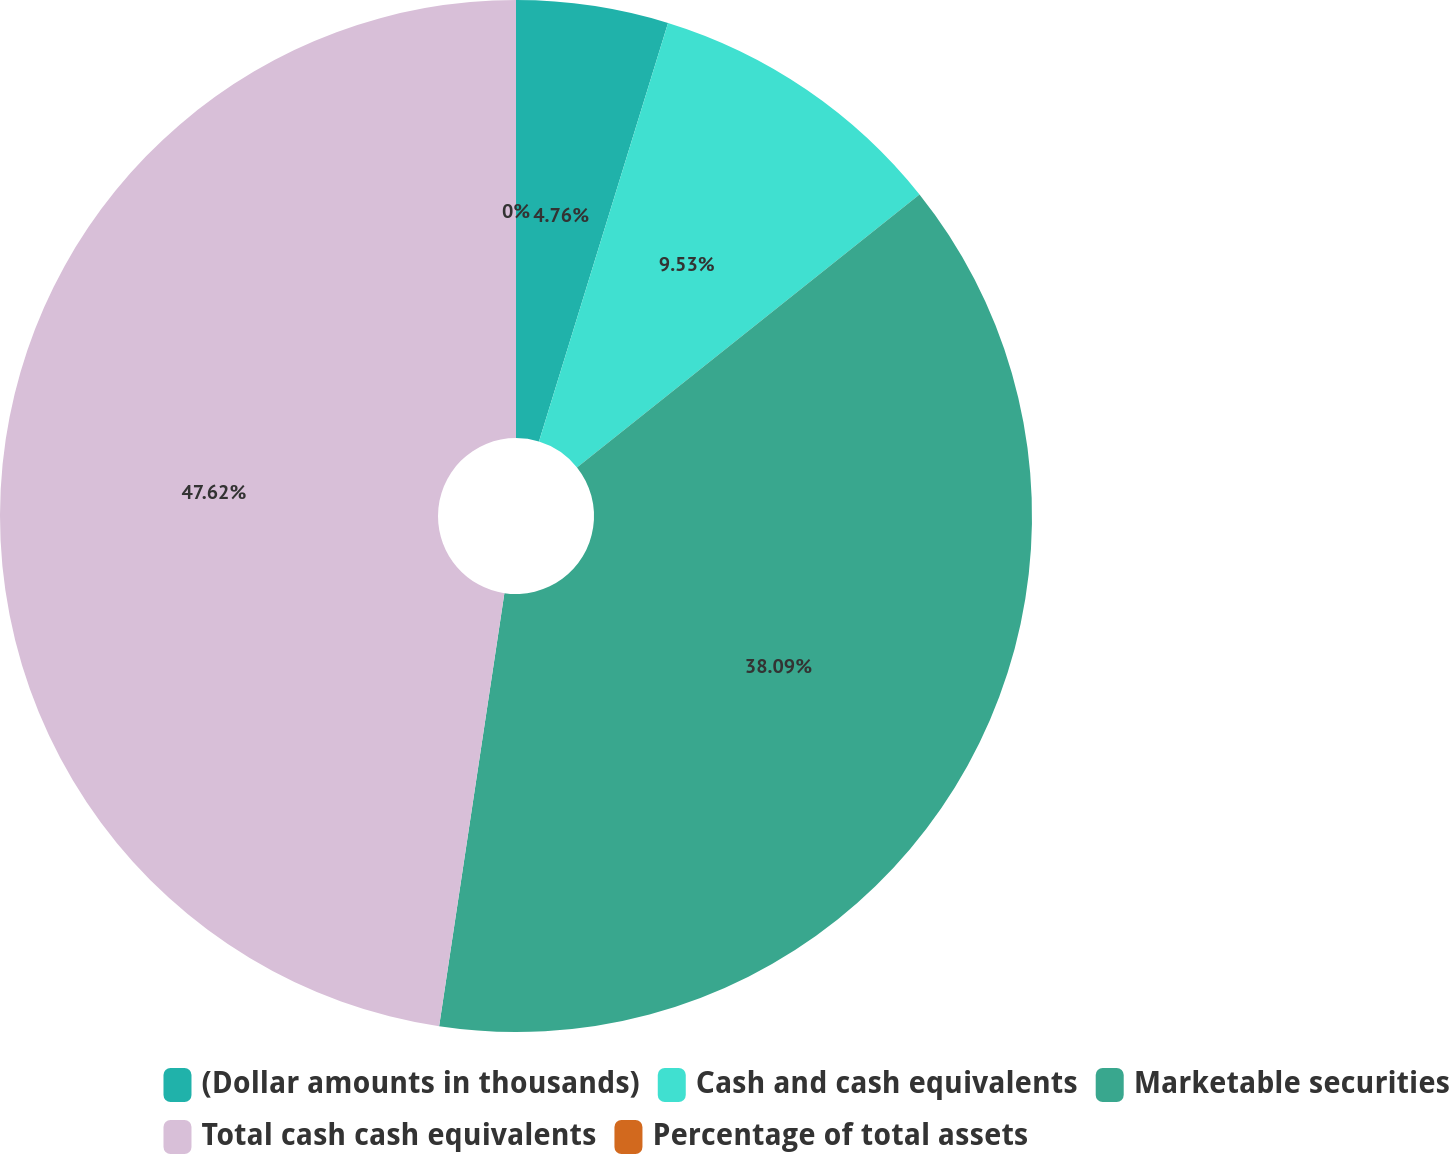Convert chart. <chart><loc_0><loc_0><loc_500><loc_500><pie_chart><fcel>(Dollar amounts in thousands)<fcel>Cash and cash equivalents<fcel>Marketable securities<fcel>Total cash cash equivalents<fcel>Percentage of total assets<nl><fcel>4.76%<fcel>9.53%<fcel>38.09%<fcel>47.62%<fcel>0.0%<nl></chart> 